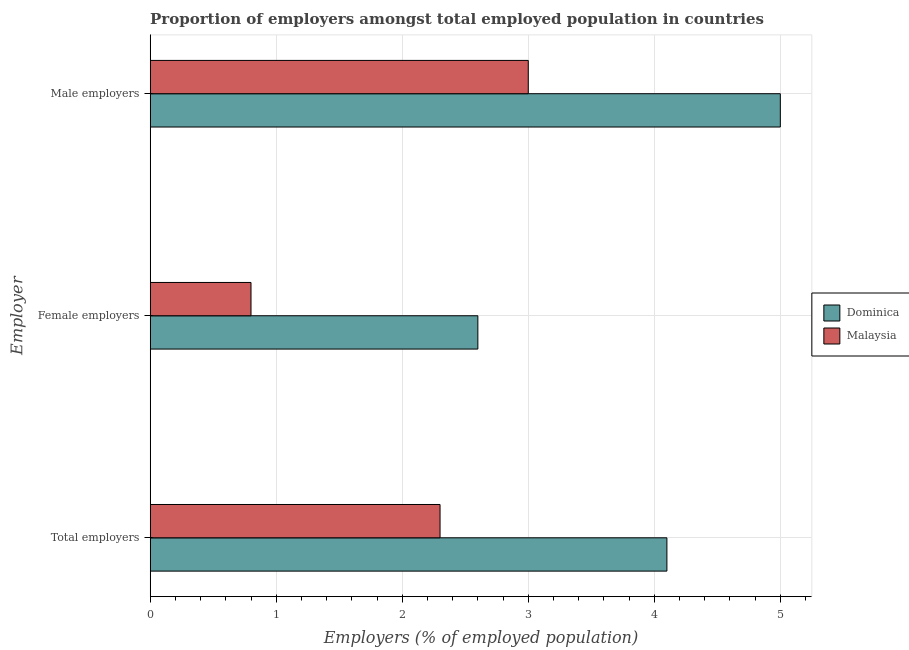How many different coloured bars are there?
Your response must be concise. 2. What is the label of the 3rd group of bars from the top?
Make the answer very short. Total employers. What is the percentage of female employers in Dominica?
Provide a short and direct response. 2.6. Across all countries, what is the maximum percentage of total employers?
Ensure brevity in your answer.  4.1. Across all countries, what is the minimum percentage of male employers?
Provide a succinct answer. 3. In which country was the percentage of female employers maximum?
Give a very brief answer. Dominica. In which country was the percentage of male employers minimum?
Your answer should be compact. Malaysia. What is the total percentage of total employers in the graph?
Your answer should be compact. 6.4. What is the difference between the percentage of total employers in Malaysia and that in Dominica?
Keep it short and to the point. -1.8. What is the difference between the percentage of total employers in Malaysia and the percentage of male employers in Dominica?
Your answer should be very brief. -2.7. What is the average percentage of female employers per country?
Ensure brevity in your answer.  1.7. What is the difference between the percentage of male employers and percentage of total employers in Malaysia?
Provide a short and direct response. 0.7. What is the ratio of the percentage of total employers in Dominica to that in Malaysia?
Provide a succinct answer. 1.78. What is the difference between the highest and the second highest percentage of male employers?
Ensure brevity in your answer.  2. What is the difference between the highest and the lowest percentage of male employers?
Offer a very short reply. 2. What does the 2nd bar from the top in Total employers represents?
Give a very brief answer. Dominica. What does the 2nd bar from the bottom in Female employers represents?
Give a very brief answer. Malaysia. Is it the case that in every country, the sum of the percentage of total employers and percentage of female employers is greater than the percentage of male employers?
Offer a very short reply. Yes. What is the difference between two consecutive major ticks on the X-axis?
Your answer should be very brief. 1. Are the values on the major ticks of X-axis written in scientific E-notation?
Make the answer very short. No. Does the graph contain any zero values?
Offer a terse response. No. Does the graph contain grids?
Offer a terse response. Yes. Where does the legend appear in the graph?
Your response must be concise. Center right. How are the legend labels stacked?
Your answer should be very brief. Vertical. What is the title of the graph?
Offer a terse response. Proportion of employers amongst total employed population in countries. What is the label or title of the X-axis?
Offer a very short reply. Employers (% of employed population). What is the label or title of the Y-axis?
Offer a terse response. Employer. What is the Employers (% of employed population) of Dominica in Total employers?
Your response must be concise. 4.1. What is the Employers (% of employed population) of Malaysia in Total employers?
Provide a short and direct response. 2.3. What is the Employers (% of employed population) of Dominica in Female employers?
Provide a short and direct response. 2.6. What is the Employers (% of employed population) of Malaysia in Female employers?
Make the answer very short. 0.8. What is the Employers (% of employed population) of Dominica in Male employers?
Make the answer very short. 5. Across all Employer, what is the maximum Employers (% of employed population) of Malaysia?
Make the answer very short. 3. Across all Employer, what is the minimum Employers (% of employed population) of Dominica?
Offer a terse response. 2.6. Across all Employer, what is the minimum Employers (% of employed population) of Malaysia?
Offer a very short reply. 0.8. What is the total Employers (% of employed population) in Dominica in the graph?
Your response must be concise. 11.7. What is the total Employers (% of employed population) in Malaysia in the graph?
Offer a very short reply. 6.1. What is the difference between the Employers (% of employed population) of Dominica in Total employers and that in Female employers?
Your answer should be compact. 1.5. What is the difference between the Employers (% of employed population) of Dominica in Total employers and that in Male employers?
Offer a very short reply. -0.9. What is the difference between the Employers (% of employed population) in Malaysia in Total employers and that in Male employers?
Offer a very short reply. -0.7. What is the difference between the Employers (% of employed population) of Dominica in Female employers and that in Male employers?
Provide a succinct answer. -2.4. What is the difference between the Employers (% of employed population) in Malaysia in Female employers and that in Male employers?
Provide a succinct answer. -2.2. What is the difference between the Employers (% of employed population) in Dominica in Female employers and the Employers (% of employed population) in Malaysia in Male employers?
Make the answer very short. -0.4. What is the average Employers (% of employed population) in Dominica per Employer?
Offer a terse response. 3.9. What is the average Employers (% of employed population) in Malaysia per Employer?
Provide a succinct answer. 2.03. What is the difference between the Employers (% of employed population) in Dominica and Employers (% of employed population) in Malaysia in Total employers?
Your answer should be very brief. 1.8. What is the ratio of the Employers (% of employed population) of Dominica in Total employers to that in Female employers?
Provide a succinct answer. 1.58. What is the ratio of the Employers (% of employed population) of Malaysia in Total employers to that in Female employers?
Offer a terse response. 2.88. What is the ratio of the Employers (% of employed population) of Dominica in Total employers to that in Male employers?
Keep it short and to the point. 0.82. What is the ratio of the Employers (% of employed population) of Malaysia in Total employers to that in Male employers?
Make the answer very short. 0.77. What is the ratio of the Employers (% of employed population) of Dominica in Female employers to that in Male employers?
Offer a terse response. 0.52. What is the ratio of the Employers (% of employed population) of Malaysia in Female employers to that in Male employers?
Make the answer very short. 0.27. What is the difference between the highest and the second highest Employers (% of employed population) of Malaysia?
Ensure brevity in your answer.  0.7. 